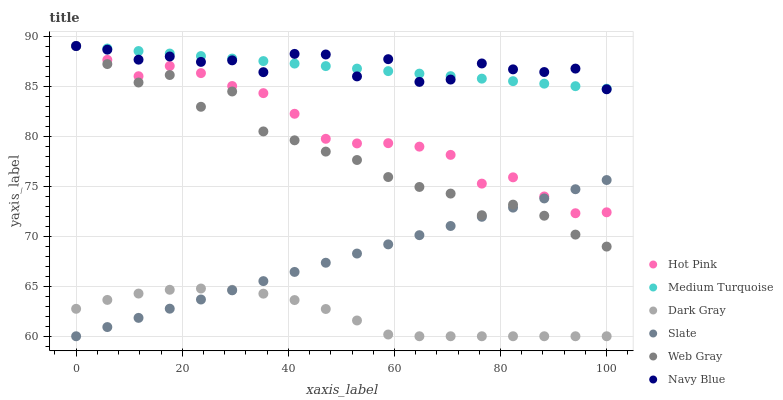Does Dark Gray have the minimum area under the curve?
Answer yes or no. Yes. Does Navy Blue have the maximum area under the curve?
Answer yes or no. Yes. Does Slate have the minimum area under the curve?
Answer yes or no. No. Does Slate have the maximum area under the curve?
Answer yes or no. No. Is Slate the smoothest?
Answer yes or no. Yes. Is Web Gray the roughest?
Answer yes or no. Yes. Is Navy Blue the smoothest?
Answer yes or no. No. Is Navy Blue the roughest?
Answer yes or no. No. Does Slate have the lowest value?
Answer yes or no. Yes. Does Navy Blue have the lowest value?
Answer yes or no. No. Does Medium Turquoise have the highest value?
Answer yes or no. Yes. Does Slate have the highest value?
Answer yes or no. No. Is Slate less than Medium Turquoise?
Answer yes or no. Yes. Is Medium Turquoise greater than Dark Gray?
Answer yes or no. Yes. Does Slate intersect Dark Gray?
Answer yes or no. Yes. Is Slate less than Dark Gray?
Answer yes or no. No. Is Slate greater than Dark Gray?
Answer yes or no. No. Does Slate intersect Medium Turquoise?
Answer yes or no. No. 